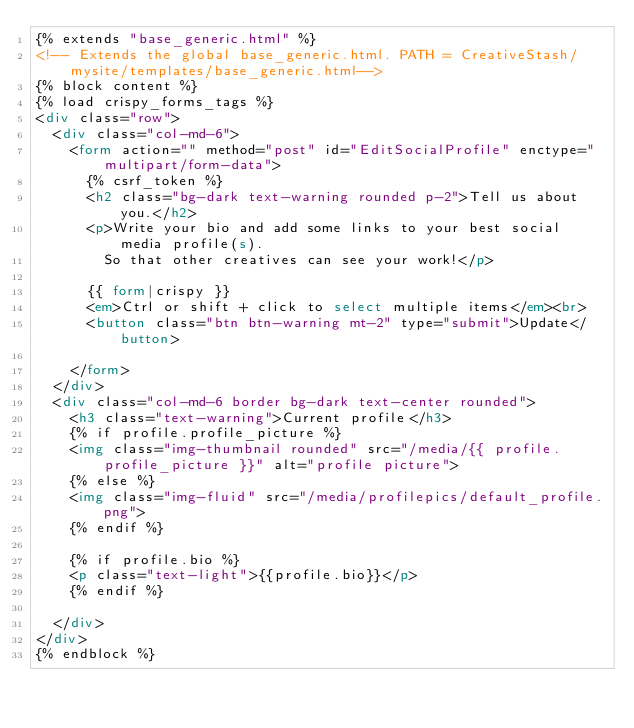Convert code to text. <code><loc_0><loc_0><loc_500><loc_500><_HTML_>{% extends "base_generic.html" %}
<!-- Extends the global base_generic.html. PATH = CreativeStash/mysite/templates/base_generic.html-->
{% block content %}
{% load crispy_forms_tags %}
<div class="row">
  <div class="col-md-6">
    <form action="" method="post" id="EditSocialProfile" enctype="multipart/form-data">
      {% csrf_token %}
      <h2 class="bg-dark text-warning rounded p-2">Tell us about you.</h2>
      <p>Write your bio and add some links to your best social media profile(s).
        So that other creatives can see your work!</p>

      {{ form|crispy }}
      <em>Ctrl or shift + click to select multiple items</em><br>
      <button class="btn btn-warning mt-2" type="submit">Update</button>

    </form>
  </div>
  <div class="col-md-6 border bg-dark text-center rounded">
    <h3 class="text-warning">Current profile</h3>
    {% if profile.profile_picture %}
    <img class="img-thumbnail rounded" src="/media/{{ profile.profile_picture }}" alt="profile picture">
    {% else %}
    <img class="img-fluid" src="/media/profilepics/default_profile.png">
    {% endif %}

    {% if profile.bio %}
    <p class="text-light">{{profile.bio}}</p>
    {% endif %}

  </div>
</div>
{% endblock %}</code> 